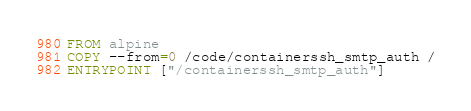<code> <loc_0><loc_0><loc_500><loc_500><_Dockerfile_>FROM alpine
COPY --from=0 /code/containerssh_smtp_auth /
ENTRYPOINT ["/containerssh_smtp_auth"]  </code> 